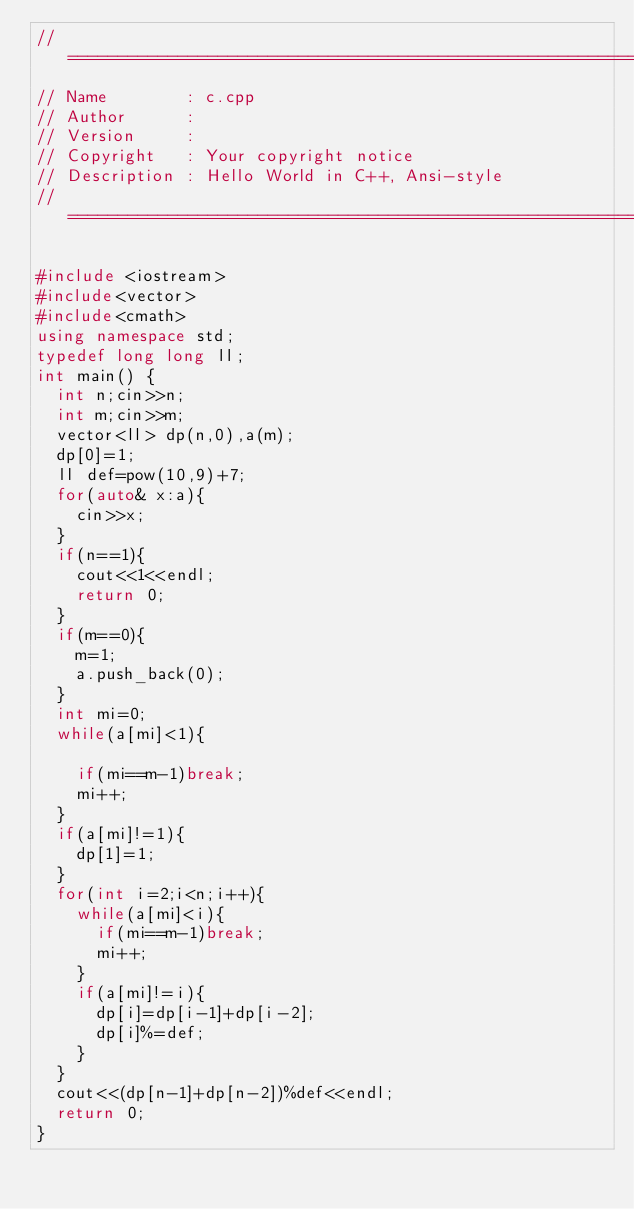Convert code to text. <code><loc_0><loc_0><loc_500><loc_500><_C++_>//============================================================================
// Name        : c.cpp
// Author      :
// Version     :
// Copyright   : Your copyright notice
// Description : Hello World in C++, Ansi-style
//============================================================================

#include <iostream>
#include<vector>
#include<cmath>
using namespace std;
typedef long long ll;
int main() {
	int n;cin>>n;
	int m;cin>>m;
	vector<ll> dp(n,0),a(m);
	dp[0]=1;
	ll def=pow(10,9)+7;
	for(auto& x:a){
		cin>>x;
	}
	if(n==1){
		cout<<1<<endl;
		return 0;
	}
	if(m==0){
		m=1;
		a.push_back(0);
	}
	int mi=0;
	while(a[mi]<1){

		if(mi==m-1)break;
		mi++;
	}
	if(a[mi]!=1){
		dp[1]=1;
	}
	for(int i=2;i<n;i++){
		while(a[mi]<i){
			if(mi==m-1)break;
			mi++;
		}
		if(a[mi]!=i){
			dp[i]=dp[i-1]+dp[i-2];
			dp[i]%=def;
		}
	}
	cout<<(dp[n-1]+dp[n-2])%def<<endl;
	return 0;
}
</code> 